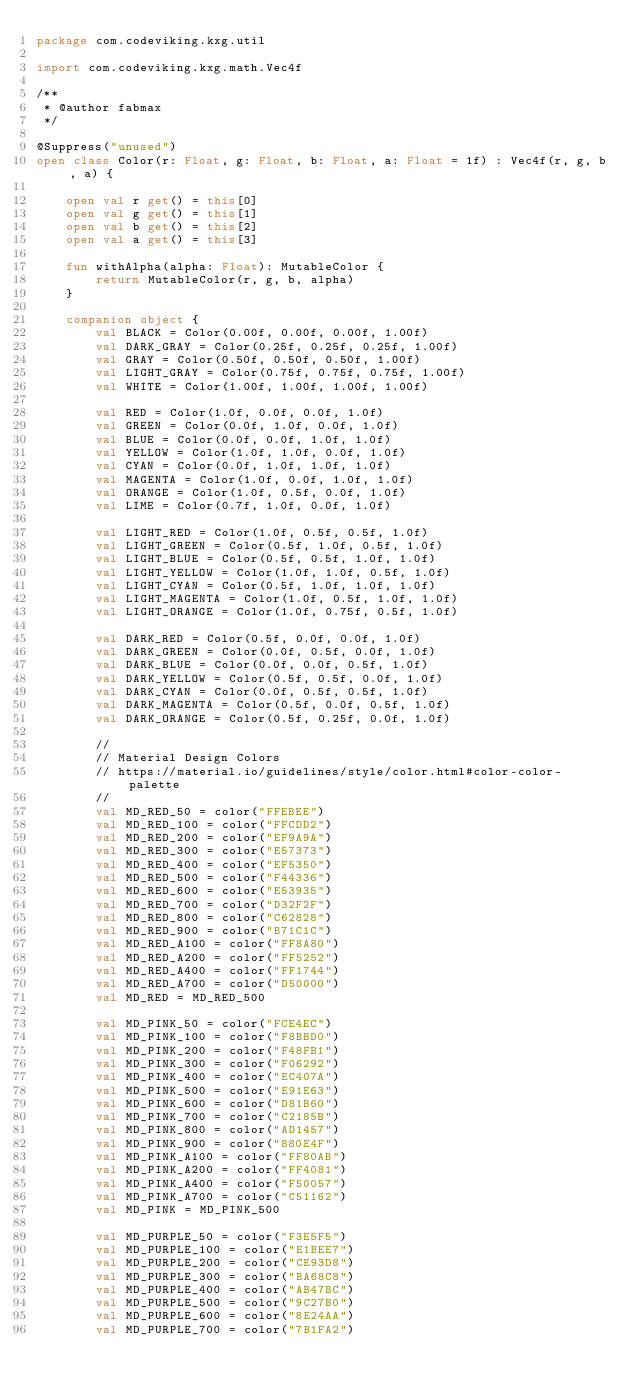Convert code to text. <code><loc_0><loc_0><loc_500><loc_500><_Kotlin_>package com.codeviking.kxg.util

import com.codeviking.kxg.math.Vec4f

/**
 * @author fabmax
 */

@Suppress("unused")
open class Color(r: Float, g: Float, b: Float, a: Float = 1f) : Vec4f(r, g, b, a) {

    open val r get() = this[0]
    open val g get() = this[1]
    open val b get() = this[2]
    open val a get() = this[3]

    fun withAlpha(alpha: Float): MutableColor {
        return MutableColor(r, g, b, alpha)
    }

    companion object {
        val BLACK = Color(0.00f, 0.00f, 0.00f, 1.00f)
        val DARK_GRAY = Color(0.25f, 0.25f, 0.25f, 1.00f)
        val GRAY = Color(0.50f, 0.50f, 0.50f, 1.00f)
        val LIGHT_GRAY = Color(0.75f, 0.75f, 0.75f, 1.00f)
        val WHITE = Color(1.00f, 1.00f, 1.00f, 1.00f)

        val RED = Color(1.0f, 0.0f, 0.0f, 1.0f)
        val GREEN = Color(0.0f, 1.0f, 0.0f, 1.0f)
        val BLUE = Color(0.0f, 0.0f, 1.0f, 1.0f)
        val YELLOW = Color(1.0f, 1.0f, 0.0f, 1.0f)
        val CYAN = Color(0.0f, 1.0f, 1.0f, 1.0f)
        val MAGENTA = Color(1.0f, 0.0f, 1.0f, 1.0f)
        val ORANGE = Color(1.0f, 0.5f, 0.0f, 1.0f)
        val LIME = Color(0.7f, 1.0f, 0.0f, 1.0f)

        val LIGHT_RED = Color(1.0f, 0.5f, 0.5f, 1.0f)
        val LIGHT_GREEN = Color(0.5f, 1.0f, 0.5f, 1.0f)
        val LIGHT_BLUE = Color(0.5f, 0.5f, 1.0f, 1.0f)
        val LIGHT_YELLOW = Color(1.0f, 1.0f, 0.5f, 1.0f)
        val LIGHT_CYAN = Color(0.5f, 1.0f, 1.0f, 1.0f)
        val LIGHT_MAGENTA = Color(1.0f, 0.5f, 1.0f, 1.0f)
        val LIGHT_ORANGE = Color(1.0f, 0.75f, 0.5f, 1.0f)

        val DARK_RED = Color(0.5f, 0.0f, 0.0f, 1.0f)
        val DARK_GREEN = Color(0.0f, 0.5f, 0.0f, 1.0f)
        val DARK_BLUE = Color(0.0f, 0.0f, 0.5f, 1.0f)
        val DARK_YELLOW = Color(0.5f, 0.5f, 0.0f, 1.0f)
        val DARK_CYAN = Color(0.0f, 0.5f, 0.5f, 1.0f)
        val DARK_MAGENTA = Color(0.5f, 0.0f, 0.5f, 1.0f)
        val DARK_ORANGE = Color(0.5f, 0.25f, 0.0f, 1.0f)

        //
        // Material Design Colors
        // https://material.io/guidelines/style/color.html#color-color-palette
        //
        val MD_RED_50 = color("FFEBEE")
        val MD_RED_100 = color("FFCDD2")
        val MD_RED_200 = color("EF9A9A")
        val MD_RED_300 = color("E57373")
        val MD_RED_400 = color("EF5350")
        val MD_RED_500 = color("F44336")
        val MD_RED_600 = color("E53935")
        val MD_RED_700 = color("D32F2F")
        val MD_RED_800 = color("C62828")
        val MD_RED_900 = color("B71C1C")
        val MD_RED_A100 = color("FF8A80")
        val MD_RED_A200 = color("FF5252")
        val MD_RED_A400 = color("FF1744")
        val MD_RED_A700 = color("D50000")
        val MD_RED = MD_RED_500

        val MD_PINK_50 = color("FCE4EC")
        val MD_PINK_100 = color("F8BBD0")
        val MD_PINK_200 = color("F48FB1")
        val MD_PINK_300 = color("F06292")
        val MD_PINK_400 = color("EC407A")
        val MD_PINK_500 = color("E91E63")
        val MD_PINK_600 = color("D81B60")
        val MD_PINK_700 = color("C2185B")
        val MD_PINK_800 = color("AD1457")
        val MD_PINK_900 = color("880E4F")
        val MD_PINK_A100 = color("FF80AB")
        val MD_PINK_A200 = color("FF4081")
        val MD_PINK_A400 = color("F50057")
        val MD_PINK_A700 = color("C51162")
        val MD_PINK = MD_PINK_500

        val MD_PURPLE_50 = color("F3E5F5")
        val MD_PURPLE_100 = color("E1BEE7")
        val MD_PURPLE_200 = color("CE93D8")
        val MD_PURPLE_300 = color("BA68C8")
        val MD_PURPLE_400 = color("AB47BC")
        val MD_PURPLE_500 = color("9C27B0")
        val MD_PURPLE_600 = color("8E24AA")
        val MD_PURPLE_700 = color("7B1FA2")</code> 